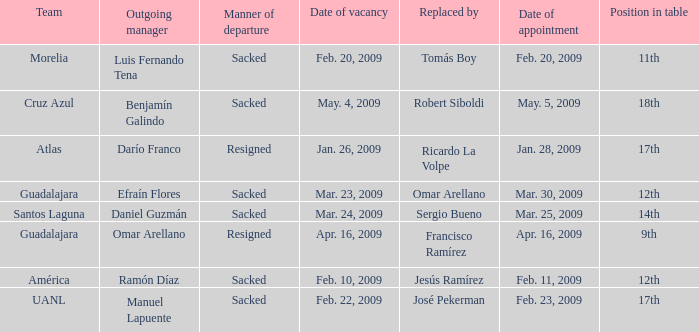What is Position in Table, when Replaced by is "José Pekerman"? 17th. 